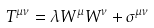<formula> <loc_0><loc_0><loc_500><loc_500>T ^ { \mu \nu } = \lambda W ^ { \mu } W ^ { \nu } + \sigma ^ { \mu \nu }</formula> 